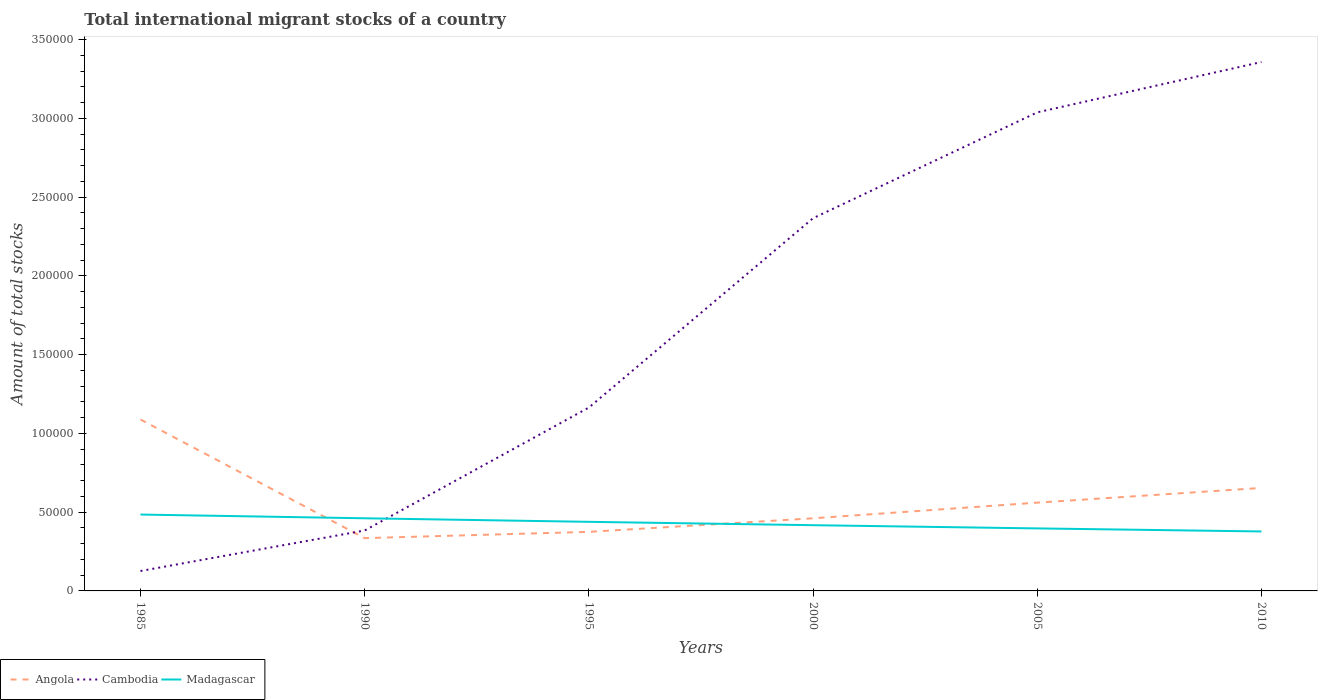Is the number of lines equal to the number of legend labels?
Provide a succinct answer. Yes. Across all years, what is the maximum amount of total stocks in in Madagascar?
Give a very brief answer. 3.78e+04. What is the total amount of total stocks in in Madagascar in the graph?
Your answer should be compact. 8791. What is the difference between the highest and the second highest amount of total stocks in in Cambodia?
Your response must be concise. 3.23e+05. What is the difference between the highest and the lowest amount of total stocks in in Madagascar?
Make the answer very short. 3. Is the amount of total stocks in in Angola strictly greater than the amount of total stocks in in Cambodia over the years?
Your answer should be very brief. No. How many lines are there?
Provide a succinct answer. 3. What is the difference between two consecutive major ticks on the Y-axis?
Ensure brevity in your answer.  5.00e+04. Does the graph contain any zero values?
Keep it short and to the point. No. Does the graph contain grids?
Offer a terse response. No. Where does the legend appear in the graph?
Keep it short and to the point. Bottom left. How many legend labels are there?
Your answer should be compact. 3. What is the title of the graph?
Give a very brief answer. Total international migrant stocks of a country. Does "Latvia" appear as one of the legend labels in the graph?
Keep it short and to the point. No. What is the label or title of the X-axis?
Keep it short and to the point. Years. What is the label or title of the Y-axis?
Provide a succinct answer. Amount of total stocks. What is the Amount of total stocks in Angola in 1985?
Your response must be concise. 1.09e+05. What is the Amount of total stocks of Cambodia in 1985?
Make the answer very short. 1.26e+04. What is the Amount of total stocks in Madagascar in 1985?
Make the answer very short. 4.85e+04. What is the Amount of total stocks of Angola in 1990?
Your answer should be compact. 3.35e+04. What is the Amount of total stocks in Cambodia in 1990?
Your answer should be compact. 3.84e+04. What is the Amount of total stocks of Madagascar in 1990?
Your response must be concise. 4.61e+04. What is the Amount of total stocks in Angola in 1995?
Offer a terse response. 3.75e+04. What is the Amount of total stocks of Cambodia in 1995?
Offer a very short reply. 1.16e+05. What is the Amount of total stocks in Madagascar in 1995?
Ensure brevity in your answer.  4.39e+04. What is the Amount of total stocks in Angola in 2000?
Offer a terse response. 4.61e+04. What is the Amount of total stocks in Cambodia in 2000?
Provide a succinct answer. 2.37e+05. What is the Amount of total stocks of Madagascar in 2000?
Provide a succinct answer. 4.17e+04. What is the Amount of total stocks in Angola in 2005?
Keep it short and to the point. 5.61e+04. What is the Amount of total stocks of Cambodia in 2005?
Give a very brief answer. 3.04e+05. What is the Amount of total stocks in Madagascar in 2005?
Offer a terse response. 3.97e+04. What is the Amount of total stocks in Angola in 2010?
Provide a short and direct response. 6.54e+04. What is the Amount of total stocks in Cambodia in 2010?
Provide a succinct answer. 3.36e+05. What is the Amount of total stocks of Madagascar in 2010?
Your response must be concise. 3.78e+04. Across all years, what is the maximum Amount of total stocks of Angola?
Your response must be concise. 1.09e+05. Across all years, what is the maximum Amount of total stocks of Cambodia?
Offer a very short reply. 3.36e+05. Across all years, what is the maximum Amount of total stocks in Madagascar?
Your response must be concise. 4.85e+04. Across all years, what is the minimum Amount of total stocks in Angola?
Provide a succinct answer. 3.35e+04. Across all years, what is the minimum Amount of total stocks in Cambodia?
Ensure brevity in your answer.  1.26e+04. Across all years, what is the minimum Amount of total stocks of Madagascar?
Ensure brevity in your answer.  3.78e+04. What is the total Amount of total stocks of Angola in the graph?
Offer a terse response. 3.47e+05. What is the total Amount of total stocks in Cambodia in the graph?
Offer a very short reply. 1.04e+06. What is the total Amount of total stocks in Madagascar in the graph?
Provide a short and direct response. 2.58e+05. What is the difference between the Amount of total stocks of Angola in 1985 and that in 1990?
Make the answer very short. 7.53e+04. What is the difference between the Amount of total stocks of Cambodia in 1985 and that in 1990?
Offer a terse response. -2.57e+04. What is the difference between the Amount of total stocks of Madagascar in 1985 and that in 1990?
Provide a short and direct response. 2365. What is the difference between the Amount of total stocks in Angola in 1985 and that in 1995?
Your response must be concise. 7.14e+04. What is the difference between the Amount of total stocks of Cambodia in 1985 and that in 1995?
Offer a terse response. -1.04e+05. What is the difference between the Amount of total stocks in Madagascar in 1985 and that in 1995?
Offer a very short reply. 4615. What is the difference between the Amount of total stocks in Angola in 1985 and that in 2000?
Your answer should be very brief. 6.27e+04. What is the difference between the Amount of total stocks of Cambodia in 1985 and that in 2000?
Your answer should be compact. -2.24e+05. What is the difference between the Amount of total stocks in Madagascar in 1985 and that in 2000?
Make the answer very short. 6755. What is the difference between the Amount of total stocks of Angola in 1985 and that in 2005?
Give a very brief answer. 5.28e+04. What is the difference between the Amount of total stocks in Cambodia in 1985 and that in 2005?
Offer a very short reply. -2.91e+05. What is the difference between the Amount of total stocks of Madagascar in 1985 and that in 2005?
Your answer should be compact. 8791. What is the difference between the Amount of total stocks in Angola in 1985 and that in 2010?
Your answer should be very brief. 4.35e+04. What is the difference between the Amount of total stocks of Cambodia in 1985 and that in 2010?
Offer a very short reply. -3.23e+05. What is the difference between the Amount of total stocks in Madagascar in 1985 and that in 2010?
Provide a short and direct response. 1.07e+04. What is the difference between the Amount of total stocks of Angola in 1990 and that in 1995?
Provide a short and direct response. -3985. What is the difference between the Amount of total stocks in Cambodia in 1990 and that in 1995?
Give a very brief answer. -7.81e+04. What is the difference between the Amount of total stocks in Madagascar in 1990 and that in 1995?
Your answer should be compact. 2250. What is the difference between the Amount of total stocks in Angola in 1990 and that in 2000?
Your response must be concise. -1.26e+04. What is the difference between the Amount of total stocks of Cambodia in 1990 and that in 2000?
Give a very brief answer. -1.98e+05. What is the difference between the Amount of total stocks in Madagascar in 1990 and that in 2000?
Offer a very short reply. 4390. What is the difference between the Amount of total stocks of Angola in 1990 and that in 2005?
Give a very brief answer. -2.25e+04. What is the difference between the Amount of total stocks of Cambodia in 1990 and that in 2005?
Provide a succinct answer. -2.65e+05. What is the difference between the Amount of total stocks of Madagascar in 1990 and that in 2005?
Your answer should be very brief. 6426. What is the difference between the Amount of total stocks of Angola in 1990 and that in 2010?
Give a very brief answer. -3.19e+04. What is the difference between the Amount of total stocks in Cambodia in 1990 and that in 2010?
Your answer should be very brief. -2.97e+05. What is the difference between the Amount of total stocks of Madagascar in 1990 and that in 2010?
Offer a very short reply. 8363. What is the difference between the Amount of total stocks in Angola in 1995 and that in 2000?
Provide a short and direct response. -8606. What is the difference between the Amount of total stocks of Cambodia in 1995 and that in 2000?
Keep it short and to the point. -1.20e+05. What is the difference between the Amount of total stocks of Madagascar in 1995 and that in 2000?
Provide a short and direct response. 2140. What is the difference between the Amount of total stocks in Angola in 1995 and that in 2005?
Ensure brevity in your answer.  -1.86e+04. What is the difference between the Amount of total stocks in Cambodia in 1995 and that in 2005?
Your answer should be compact. -1.87e+05. What is the difference between the Amount of total stocks in Madagascar in 1995 and that in 2005?
Your answer should be very brief. 4176. What is the difference between the Amount of total stocks in Angola in 1995 and that in 2010?
Ensure brevity in your answer.  -2.79e+04. What is the difference between the Amount of total stocks in Cambodia in 1995 and that in 2010?
Ensure brevity in your answer.  -2.19e+05. What is the difference between the Amount of total stocks in Madagascar in 1995 and that in 2010?
Give a very brief answer. 6113. What is the difference between the Amount of total stocks of Angola in 2000 and that in 2005?
Offer a very short reply. -9947. What is the difference between the Amount of total stocks of Cambodia in 2000 and that in 2005?
Keep it short and to the point. -6.72e+04. What is the difference between the Amount of total stocks in Madagascar in 2000 and that in 2005?
Ensure brevity in your answer.  2036. What is the difference between the Amount of total stocks in Angola in 2000 and that in 2010?
Give a very brief answer. -1.93e+04. What is the difference between the Amount of total stocks of Cambodia in 2000 and that in 2010?
Keep it short and to the point. -9.92e+04. What is the difference between the Amount of total stocks in Madagascar in 2000 and that in 2010?
Keep it short and to the point. 3973. What is the difference between the Amount of total stocks in Angola in 2005 and that in 2010?
Your answer should be very brief. -9332. What is the difference between the Amount of total stocks of Cambodia in 2005 and that in 2010?
Your answer should be compact. -3.20e+04. What is the difference between the Amount of total stocks in Madagascar in 2005 and that in 2010?
Your answer should be compact. 1937. What is the difference between the Amount of total stocks of Angola in 1985 and the Amount of total stocks of Cambodia in 1990?
Make the answer very short. 7.05e+04. What is the difference between the Amount of total stocks in Angola in 1985 and the Amount of total stocks in Madagascar in 1990?
Make the answer very short. 6.27e+04. What is the difference between the Amount of total stocks of Cambodia in 1985 and the Amount of total stocks of Madagascar in 1990?
Provide a short and direct response. -3.35e+04. What is the difference between the Amount of total stocks in Angola in 1985 and the Amount of total stocks in Cambodia in 1995?
Offer a very short reply. -7587. What is the difference between the Amount of total stocks in Angola in 1985 and the Amount of total stocks in Madagascar in 1995?
Provide a succinct answer. 6.50e+04. What is the difference between the Amount of total stocks of Cambodia in 1985 and the Amount of total stocks of Madagascar in 1995?
Provide a short and direct response. -3.12e+04. What is the difference between the Amount of total stocks in Angola in 1985 and the Amount of total stocks in Cambodia in 2000?
Keep it short and to the point. -1.28e+05. What is the difference between the Amount of total stocks of Angola in 1985 and the Amount of total stocks of Madagascar in 2000?
Provide a succinct answer. 6.71e+04. What is the difference between the Amount of total stocks in Cambodia in 1985 and the Amount of total stocks in Madagascar in 2000?
Keep it short and to the point. -2.91e+04. What is the difference between the Amount of total stocks of Angola in 1985 and the Amount of total stocks of Cambodia in 2005?
Offer a terse response. -1.95e+05. What is the difference between the Amount of total stocks of Angola in 1985 and the Amount of total stocks of Madagascar in 2005?
Offer a terse response. 6.92e+04. What is the difference between the Amount of total stocks in Cambodia in 1985 and the Amount of total stocks in Madagascar in 2005?
Make the answer very short. -2.71e+04. What is the difference between the Amount of total stocks of Angola in 1985 and the Amount of total stocks of Cambodia in 2010?
Your answer should be compact. -2.27e+05. What is the difference between the Amount of total stocks in Angola in 1985 and the Amount of total stocks in Madagascar in 2010?
Keep it short and to the point. 7.11e+04. What is the difference between the Amount of total stocks in Cambodia in 1985 and the Amount of total stocks in Madagascar in 2010?
Your response must be concise. -2.51e+04. What is the difference between the Amount of total stocks of Angola in 1990 and the Amount of total stocks of Cambodia in 1995?
Your response must be concise. -8.29e+04. What is the difference between the Amount of total stocks of Angola in 1990 and the Amount of total stocks of Madagascar in 1995?
Your response must be concise. -1.04e+04. What is the difference between the Amount of total stocks in Cambodia in 1990 and the Amount of total stocks in Madagascar in 1995?
Offer a terse response. -5500. What is the difference between the Amount of total stocks of Angola in 1990 and the Amount of total stocks of Cambodia in 2000?
Give a very brief answer. -2.03e+05. What is the difference between the Amount of total stocks in Angola in 1990 and the Amount of total stocks in Madagascar in 2000?
Provide a short and direct response. -8218. What is the difference between the Amount of total stocks in Cambodia in 1990 and the Amount of total stocks in Madagascar in 2000?
Provide a succinct answer. -3360. What is the difference between the Amount of total stocks in Angola in 1990 and the Amount of total stocks in Cambodia in 2005?
Keep it short and to the point. -2.70e+05. What is the difference between the Amount of total stocks in Angola in 1990 and the Amount of total stocks in Madagascar in 2005?
Keep it short and to the point. -6182. What is the difference between the Amount of total stocks of Cambodia in 1990 and the Amount of total stocks of Madagascar in 2005?
Provide a succinct answer. -1324. What is the difference between the Amount of total stocks of Angola in 1990 and the Amount of total stocks of Cambodia in 2010?
Offer a terse response. -3.02e+05. What is the difference between the Amount of total stocks in Angola in 1990 and the Amount of total stocks in Madagascar in 2010?
Give a very brief answer. -4245. What is the difference between the Amount of total stocks in Cambodia in 1990 and the Amount of total stocks in Madagascar in 2010?
Keep it short and to the point. 613. What is the difference between the Amount of total stocks in Angola in 1995 and the Amount of total stocks in Cambodia in 2000?
Your answer should be very brief. -1.99e+05. What is the difference between the Amount of total stocks in Angola in 1995 and the Amount of total stocks in Madagascar in 2000?
Keep it short and to the point. -4233. What is the difference between the Amount of total stocks in Cambodia in 1995 and the Amount of total stocks in Madagascar in 2000?
Ensure brevity in your answer.  7.47e+04. What is the difference between the Amount of total stocks in Angola in 1995 and the Amount of total stocks in Cambodia in 2005?
Give a very brief answer. -2.66e+05. What is the difference between the Amount of total stocks in Angola in 1995 and the Amount of total stocks in Madagascar in 2005?
Provide a short and direct response. -2197. What is the difference between the Amount of total stocks of Cambodia in 1995 and the Amount of total stocks of Madagascar in 2005?
Your answer should be compact. 7.67e+04. What is the difference between the Amount of total stocks in Angola in 1995 and the Amount of total stocks in Cambodia in 2010?
Your answer should be compact. -2.98e+05. What is the difference between the Amount of total stocks of Angola in 1995 and the Amount of total stocks of Madagascar in 2010?
Your answer should be compact. -260. What is the difference between the Amount of total stocks of Cambodia in 1995 and the Amount of total stocks of Madagascar in 2010?
Your answer should be very brief. 7.87e+04. What is the difference between the Amount of total stocks of Angola in 2000 and the Amount of total stocks of Cambodia in 2005?
Give a very brief answer. -2.58e+05. What is the difference between the Amount of total stocks in Angola in 2000 and the Amount of total stocks in Madagascar in 2005?
Keep it short and to the point. 6409. What is the difference between the Amount of total stocks of Cambodia in 2000 and the Amount of total stocks of Madagascar in 2005?
Offer a very short reply. 1.97e+05. What is the difference between the Amount of total stocks in Angola in 2000 and the Amount of total stocks in Cambodia in 2010?
Your answer should be very brief. -2.90e+05. What is the difference between the Amount of total stocks of Angola in 2000 and the Amount of total stocks of Madagascar in 2010?
Provide a succinct answer. 8346. What is the difference between the Amount of total stocks in Cambodia in 2000 and the Amount of total stocks in Madagascar in 2010?
Your response must be concise. 1.99e+05. What is the difference between the Amount of total stocks in Angola in 2005 and the Amount of total stocks in Cambodia in 2010?
Offer a very short reply. -2.80e+05. What is the difference between the Amount of total stocks of Angola in 2005 and the Amount of total stocks of Madagascar in 2010?
Your answer should be compact. 1.83e+04. What is the difference between the Amount of total stocks in Cambodia in 2005 and the Amount of total stocks in Madagascar in 2010?
Make the answer very short. 2.66e+05. What is the average Amount of total stocks of Angola per year?
Provide a succinct answer. 5.79e+04. What is the average Amount of total stocks in Cambodia per year?
Provide a short and direct response. 1.74e+05. What is the average Amount of total stocks of Madagascar per year?
Your answer should be compact. 4.29e+04. In the year 1985, what is the difference between the Amount of total stocks of Angola and Amount of total stocks of Cambodia?
Offer a very short reply. 9.62e+04. In the year 1985, what is the difference between the Amount of total stocks of Angola and Amount of total stocks of Madagascar?
Give a very brief answer. 6.04e+04. In the year 1985, what is the difference between the Amount of total stocks of Cambodia and Amount of total stocks of Madagascar?
Provide a succinct answer. -3.58e+04. In the year 1990, what is the difference between the Amount of total stocks of Angola and Amount of total stocks of Cambodia?
Your answer should be compact. -4858. In the year 1990, what is the difference between the Amount of total stocks in Angola and Amount of total stocks in Madagascar?
Give a very brief answer. -1.26e+04. In the year 1990, what is the difference between the Amount of total stocks in Cambodia and Amount of total stocks in Madagascar?
Your answer should be compact. -7750. In the year 1995, what is the difference between the Amount of total stocks in Angola and Amount of total stocks in Cambodia?
Your response must be concise. -7.89e+04. In the year 1995, what is the difference between the Amount of total stocks of Angola and Amount of total stocks of Madagascar?
Offer a terse response. -6373. In the year 1995, what is the difference between the Amount of total stocks in Cambodia and Amount of total stocks in Madagascar?
Give a very brief answer. 7.26e+04. In the year 2000, what is the difference between the Amount of total stocks in Angola and Amount of total stocks in Cambodia?
Make the answer very short. -1.91e+05. In the year 2000, what is the difference between the Amount of total stocks in Angola and Amount of total stocks in Madagascar?
Give a very brief answer. 4373. In the year 2000, what is the difference between the Amount of total stocks in Cambodia and Amount of total stocks in Madagascar?
Your answer should be very brief. 1.95e+05. In the year 2005, what is the difference between the Amount of total stocks in Angola and Amount of total stocks in Cambodia?
Provide a succinct answer. -2.48e+05. In the year 2005, what is the difference between the Amount of total stocks in Angola and Amount of total stocks in Madagascar?
Your answer should be compact. 1.64e+04. In the year 2005, what is the difference between the Amount of total stocks of Cambodia and Amount of total stocks of Madagascar?
Offer a terse response. 2.64e+05. In the year 2010, what is the difference between the Amount of total stocks of Angola and Amount of total stocks of Cambodia?
Offer a very short reply. -2.70e+05. In the year 2010, what is the difference between the Amount of total stocks in Angola and Amount of total stocks in Madagascar?
Offer a terse response. 2.76e+04. In the year 2010, what is the difference between the Amount of total stocks of Cambodia and Amount of total stocks of Madagascar?
Keep it short and to the point. 2.98e+05. What is the ratio of the Amount of total stocks in Angola in 1985 to that in 1990?
Offer a terse response. 3.25. What is the ratio of the Amount of total stocks of Cambodia in 1985 to that in 1990?
Your answer should be compact. 0.33. What is the ratio of the Amount of total stocks of Madagascar in 1985 to that in 1990?
Your response must be concise. 1.05. What is the ratio of the Amount of total stocks in Angola in 1985 to that in 1995?
Make the answer very short. 2.9. What is the ratio of the Amount of total stocks of Cambodia in 1985 to that in 1995?
Make the answer very short. 0.11. What is the ratio of the Amount of total stocks of Madagascar in 1985 to that in 1995?
Keep it short and to the point. 1.11. What is the ratio of the Amount of total stocks of Angola in 1985 to that in 2000?
Keep it short and to the point. 2.36. What is the ratio of the Amount of total stocks in Cambodia in 1985 to that in 2000?
Provide a succinct answer. 0.05. What is the ratio of the Amount of total stocks of Madagascar in 1985 to that in 2000?
Your answer should be very brief. 1.16. What is the ratio of the Amount of total stocks of Angola in 1985 to that in 2005?
Give a very brief answer. 1.94. What is the ratio of the Amount of total stocks in Cambodia in 1985 to that in 2005?
Provide a succinct answer. 0.04. What is the ratio of the Amount of total stocks of Madagascar in 1985 to that in 2005?
Offer a very short reply. 1.22. What is the ratio of the Amount of total stocks of Angola in 1985 to that in 2010?
Your answer should be very brief. 1.66. What is the ratio of the Amount of total stocks of Cambodia in 1985 to that in 2010?
Make the answer very short. 0.04. What is the ratio of the Amount of total stocks of Madagascar in 1985 to that in 2010?
Provide a succinct answer. 1.28. What is the ratio of the Amount of total stocks of Angola in 1990 to that in 1995?
Your response must be concise. 0.89. What is the ratio of the Amount of total stocks of Cambodia in 1990 to that in 1995?
Your answer should be compact. 0.33. What is the ratio of the Amount of total stocks in Madagascar in 1990 to that in 1995?
Provide a short and direct response. 1.05. What is the ratio of the Amount of total stocks of Angola in 1990 to that in 2000?
Provide a succinct answer. 0.73. What is the ratio of the Amount of total stocks in Cambodia in 1990 to that in 2000?
Offer a terse response. 0.16. What is the ratio of the Amount of total stocks of Madagascar in 1990 to that in 2000?
Your answer should be very brief. 1.11. What is the ratio of the Amount of total stocks of Angola in 1990 to that in 2005?
Provide a succinct answer. 0.6. What is the ratio of the Amount of total stocks of Cambodia in 1990 to that in 2005?
Offer a terse response. 0.13. What is the ratio of the Amount of total stocks of Madagascar in 1990 to that in 2005?
Provide a succinct answer. 1.16. What is the ratio of the Amount of total stocks in Angola in 1990 to that in 2010?
Your response must be concise. 0.51. What is the ratio of the Amount of total stocks of Cambodia in 1990 to that in 2010?
Offer a terse response. 0.11. What is the ratio of the Amount of total stocks of Madagascar in 1990 to that in 2010?
Offer a terse response. 1.22. What is the ratio of the Amount of total stocks in Angola in 1995 to that in 2000?
Offer a terse response. 0.81. What is the ratio of the Amount of total stocks in Cambodia in 1995 to that in 2000?
Ensure brevity in your answer.  0.49. What is the ratio of the Amount of total stocks in Madagascar in 1995 to that in 2000?
Keep it short and to the point. 1.05. What is the ratio of the Amount of total stocks in Angola in 1995 to that in 2005?
Keep it short and to the point. 0.67. What is the ratio of the Amount of total stocks in Cambodia in 1995 to that in 2005?
Offer a terse response. 0.38. What is the ratio of the Amount of total stocks in Madagascar in 1995 to that in 2005?
Make the answer very short. 1.11. What is the ratio of the Amount of total stocks in Angola in 1995 to that in 2010?
Offer a terse response. 0.57. What is the ratio of the Amount of total stocks in Cambodia in 1995 to that in 2010?
Offer a very short reply. 0.35. What is the ratio of the Amount of total stocks in Madagascar in 1995 to that in 2010?
Give a very brief answer. 1.16. What is the ratio of the Amount of total stocks of Angola in 2000 to that in 2005?
Give a very brief answer. 0.82. What is the ratio of the Amount of total stocks in Cambodia in 2000 to that in 2005?
Your answer should be compact. 0.78. What is the ratio of the Amount of total stocks of Madagascar in 2000 to that in 2005?
Your answer should be compact. 1.05. What is the ratio of the Amount of total stocks of Angola in 2000 to that in 2010?
Offer a very short reply. 0.71. What is the ratio of the Amount of total stocks in Cambodia in 2000 to that in 2010?
Your answer should be very brief. 0.7. What is the ratio of the Amount of total stocks of Madagascar in 2000 to that in 2010?
Your answer should be compact. 1.11. What is the ratio of the Amount of total stocks of Angola in 2005 to that in 2010?
Your answer should be compact. 0.86. What is the ratio of the Amount of total stocks of Cambodia in 2005 to that in 2010?
Your response must be concise. 0.9. What is the ratio of the Amount of total stocks of Madagascar in 2005 to that in 2010?
Make the answer very short. 1.05. What is the difference between the highest and the second highest Amount of total stocks of Angola?
Provide a short and direct response. 4.35e+04. What is the difference between the highest and the second highest Amount of total stocks in Cambodia?
Your answer should be very brief. 3.20e+04. What is the difference between the highest and the second highest Amount of total stocks of Madagascar?
Give a very brief answer. 2365. What is the difference between the highest and the lowest Amount of total stocks of Angola?
Provide a short and direct response. 7.53e+04. What is the difference between the highest and the lowest Amount of total stocks in Cambodia?
Keep it short and to the point. 3.23e+05. What is the difference between the highest and the lowest Amount of total stocks in Madagascar?
Ensure brevity in your answer.  1.07e+04. 